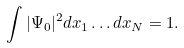<formula> <loc_0><loc_0><loc_500><loc_500>\int | \Psi _ { 0 } | ^ { 2 } d x _ { 1 } \dots d x _ { N } = 1 .</formula> 